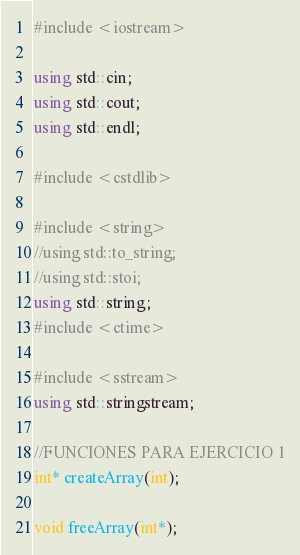Convert code to text. <code><loc_0><loc_0><loc_500><loc_500><_C++_>#include <iostream>

using std::cin;
using std::cout;
using std::endl;

#include <cstdlib>

#include <string>
//using std::to_string;
//using std::stoi;
using std::string;
#include <ctime>

#include <sstream>
using std::stringstream;

//FUNCIONES PARA EJERCICIO 1
int* createArray(int);

void freeArray(int*);
</code> 